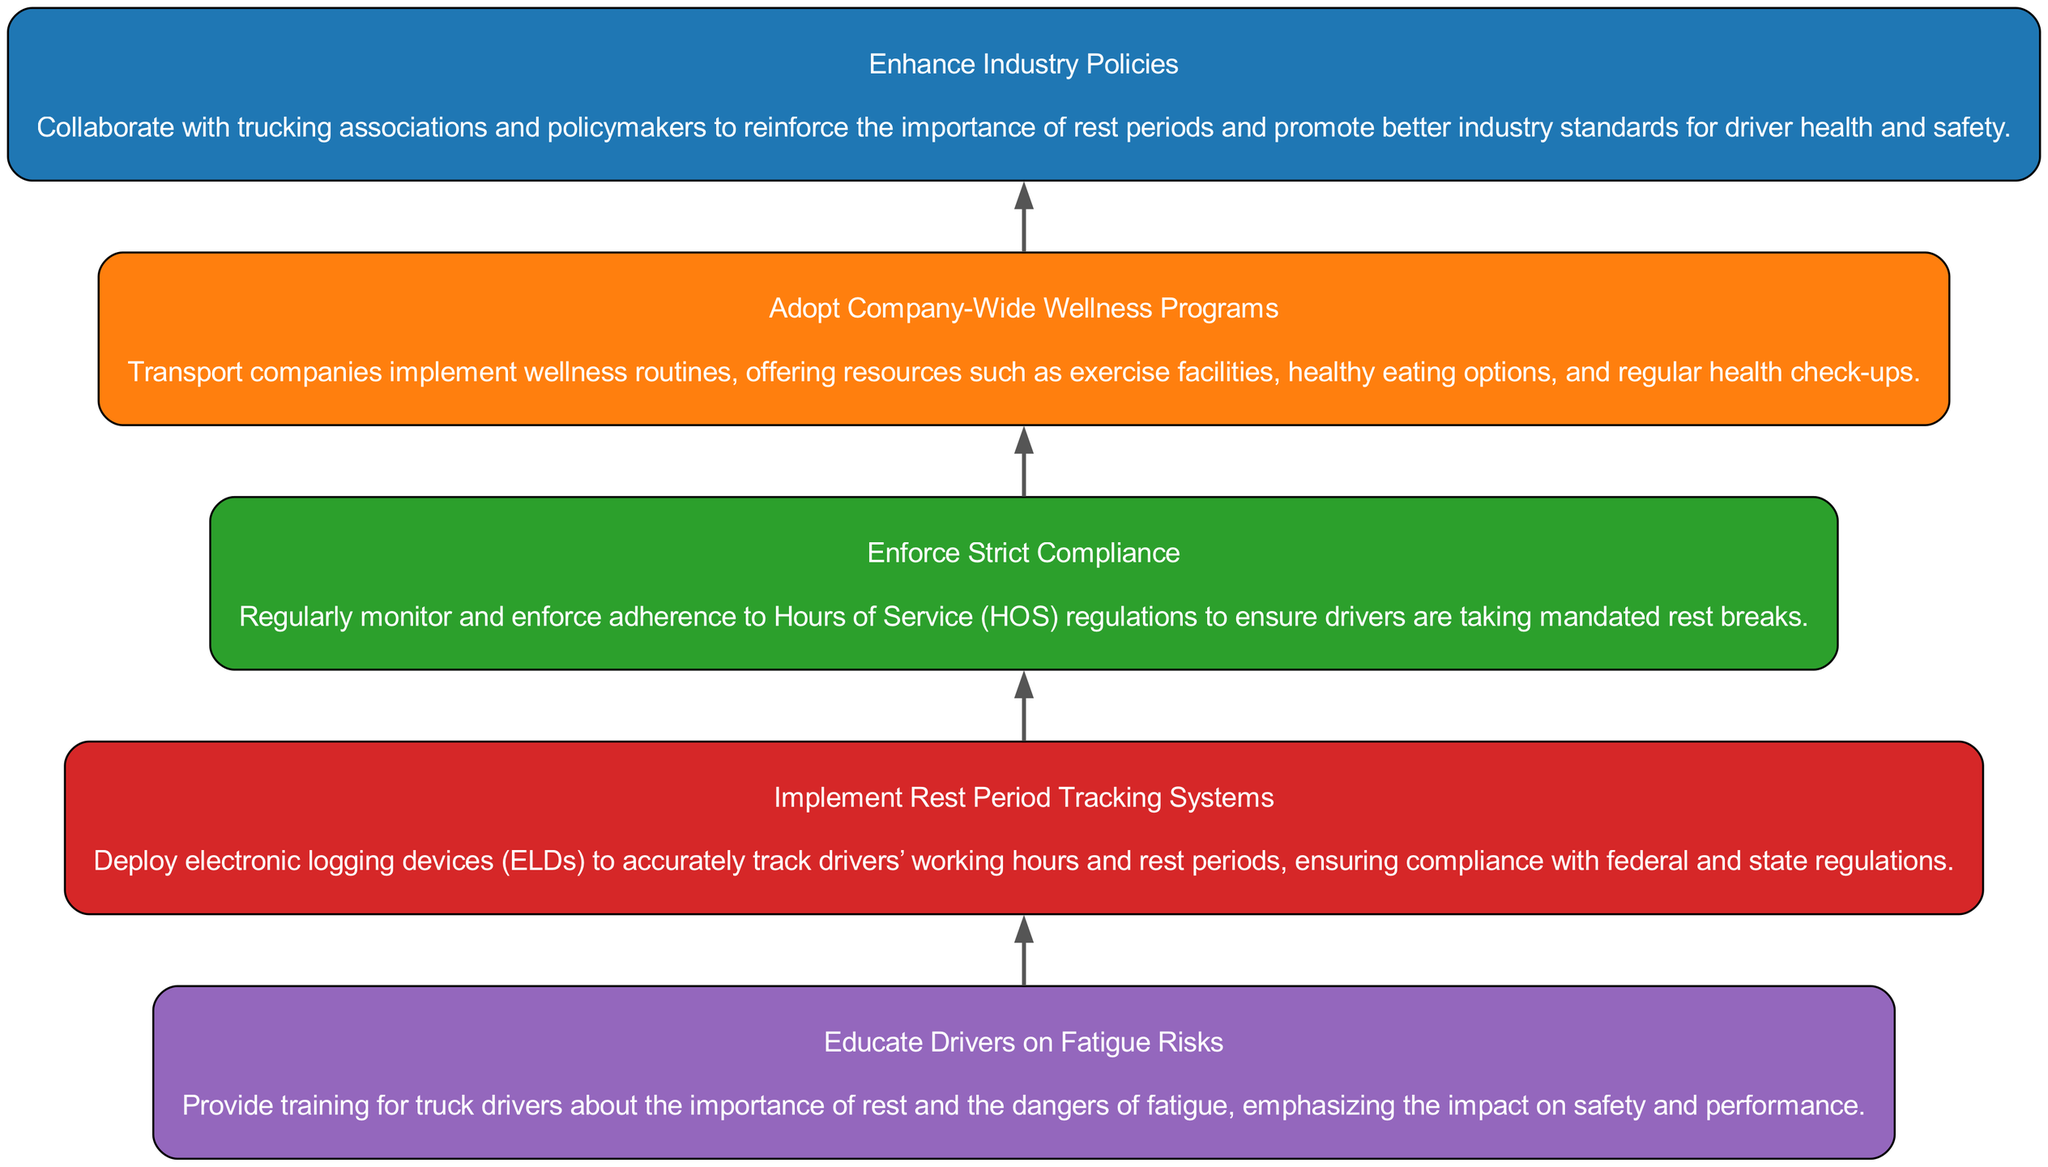What is the final step in the flow chart? The final step is "Enhance Industry Policies" which is positioned at the top of the diagram and has no dependencies.
Answer: Enhance Industry Policies How many steps are there in total? There are five steps depicted in the diagram, with each one building upon the previous step.
Answer: 5 What is the main action in Step 3? Step 3 is "Enforce Strict Compliance" which focuses on monitoring adherence to Hours of Service regulations.
Answer: Enforce Strict Compliance Which step introduces the concept of tracking systems? Step 2 introduces "Implement Rest Period Tracking Systems," which pertains to the use of electronic logging devices.
Answer: Implement Rest Period Tracking Systems What precedes "Enhance Industry Policies"? "Adopt Company-Wide Wellness Programs" is the step that directly precedes "Enhance Industry Policies," indicating that wellness programs must be in place first.
Answer: Adopt Company-Wide Wellness Programs What is the primary goal of Step 1? The primary goal of Step 1 is "Educate Drivers on Fatigue Risks," which emphasizes the importance of understanding the dangers of fatigue.
Answer: Educate Drivers on Fatigue Risks How many dependencies does Step 4 have? Step 4 has one dependency, as it can only be implemented after Step 3 has been completed.
Answer: 1 What does Step 5 aim to do? Step 5 aims to collaborate with trucking associations and policymakers to reinforce the importance of rest periods and promote industry standards.
Answer: Enhance Industry Policies What color is used for Step 1? Step 1 is represented in the color blue, according to the color palette used in the diagram.
Answer: Blue 